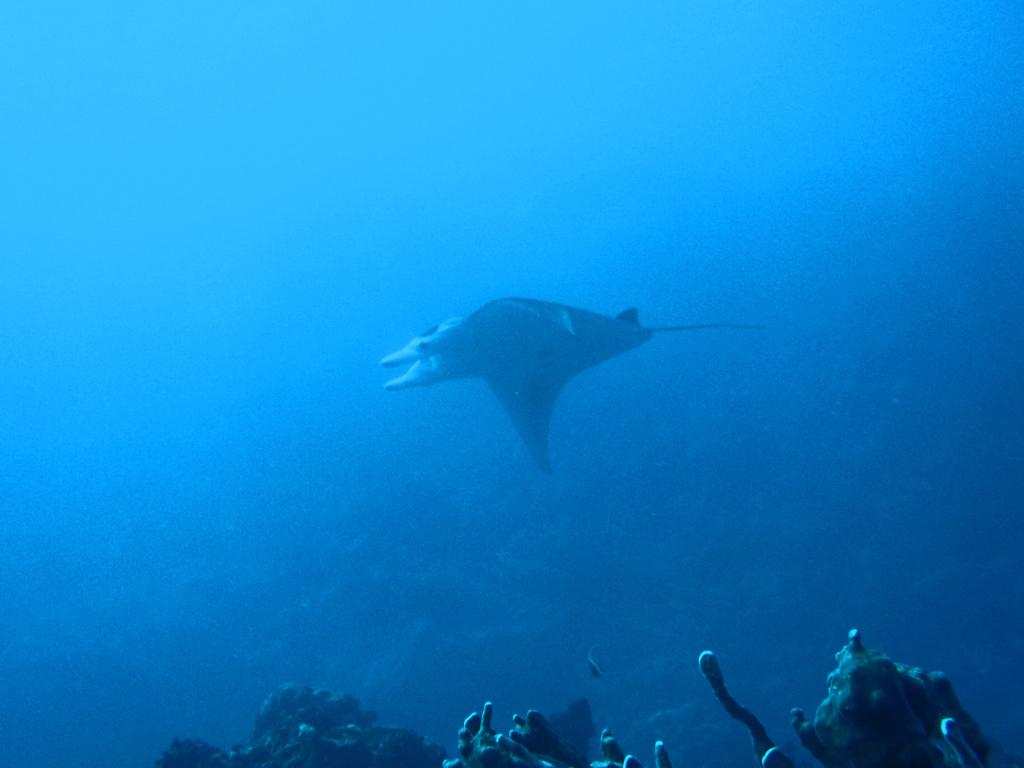What type of animal can be seen in the image? There is an aquatic animal in the image. What color is the background of the image? The background of the image is blue. What design is being offered by the smoke in the image? There is no smoke present in the image, so no design can be offered. 